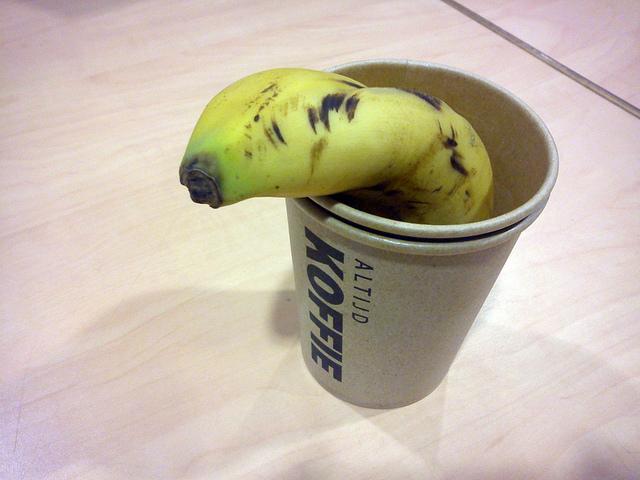Is the banana a traditional banana shape?
Short answer required. No. Has someone eaten this banana yet?
Be succinct. Yes. What does the cup say?
Be succinct. Altijd koffie. 